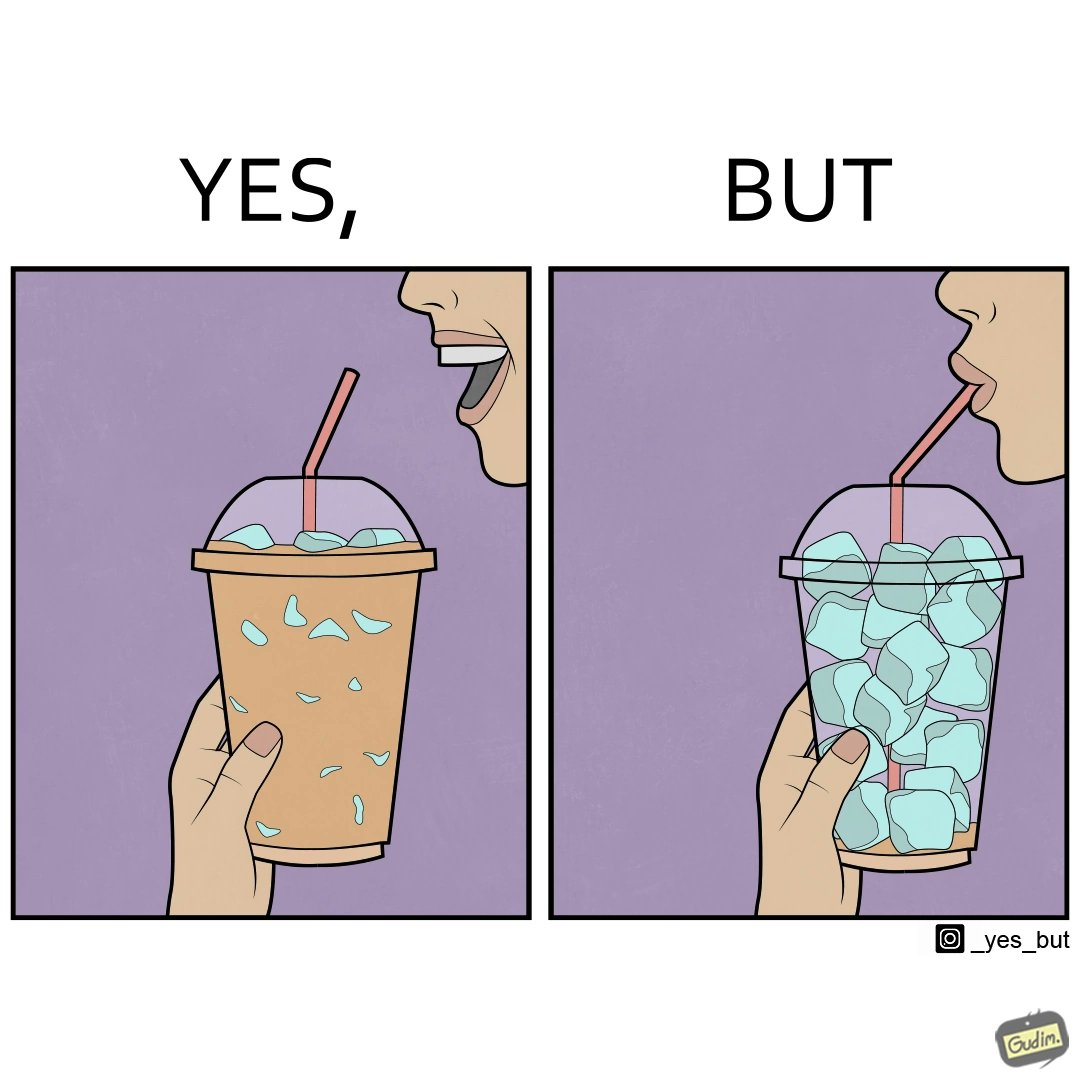What is the satirical meaning behind this image? The image is funny, as the drink seems to be full to begin with, while most of the volume of the drink is occupied by the ice cubes. 